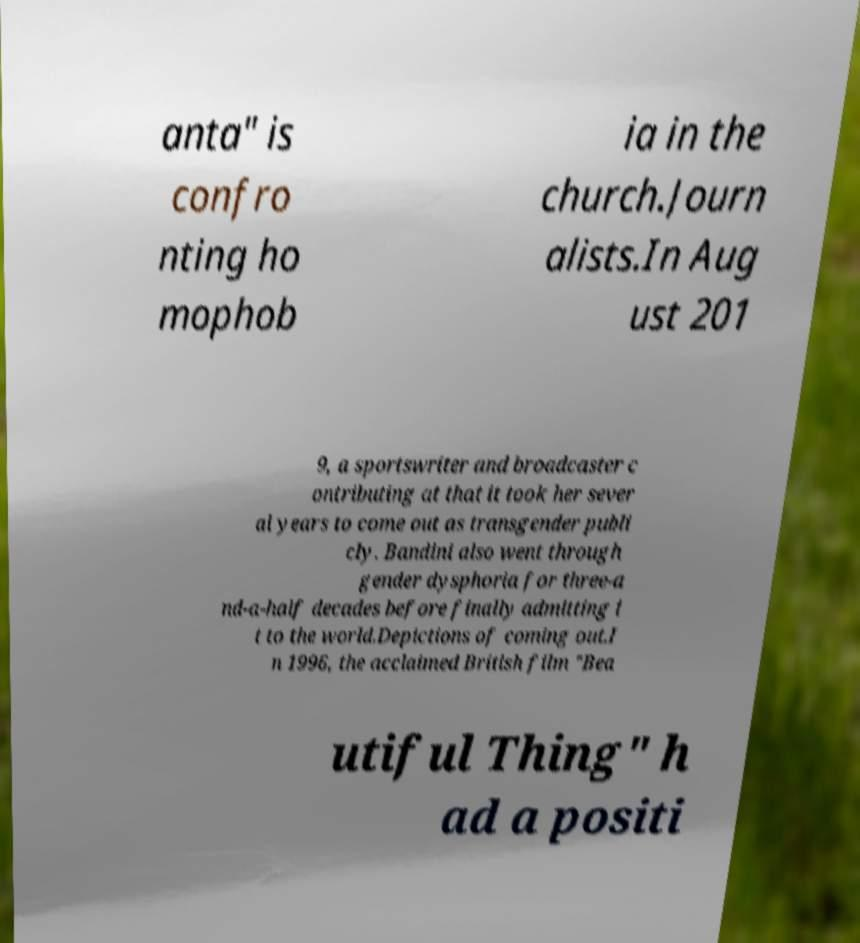Can you read and provide the text displayed in the image?This photo seems to have some interesting text. Can you extract and type it out for me? anta" is confro nting ho mophob ia in the church.Journ alists.In Aug ust 201 9, a sportswriter and broadcaster c ontributing at that it took her sever al years to come out as transgender publi cly. Bandini also went through gender dysphoria for three-a nd-a-half decades before finally admitting i t to the world.Depictions of coming out.I n 1996, the acclaimed British film "Bea utiful Thing" h ad a positi 